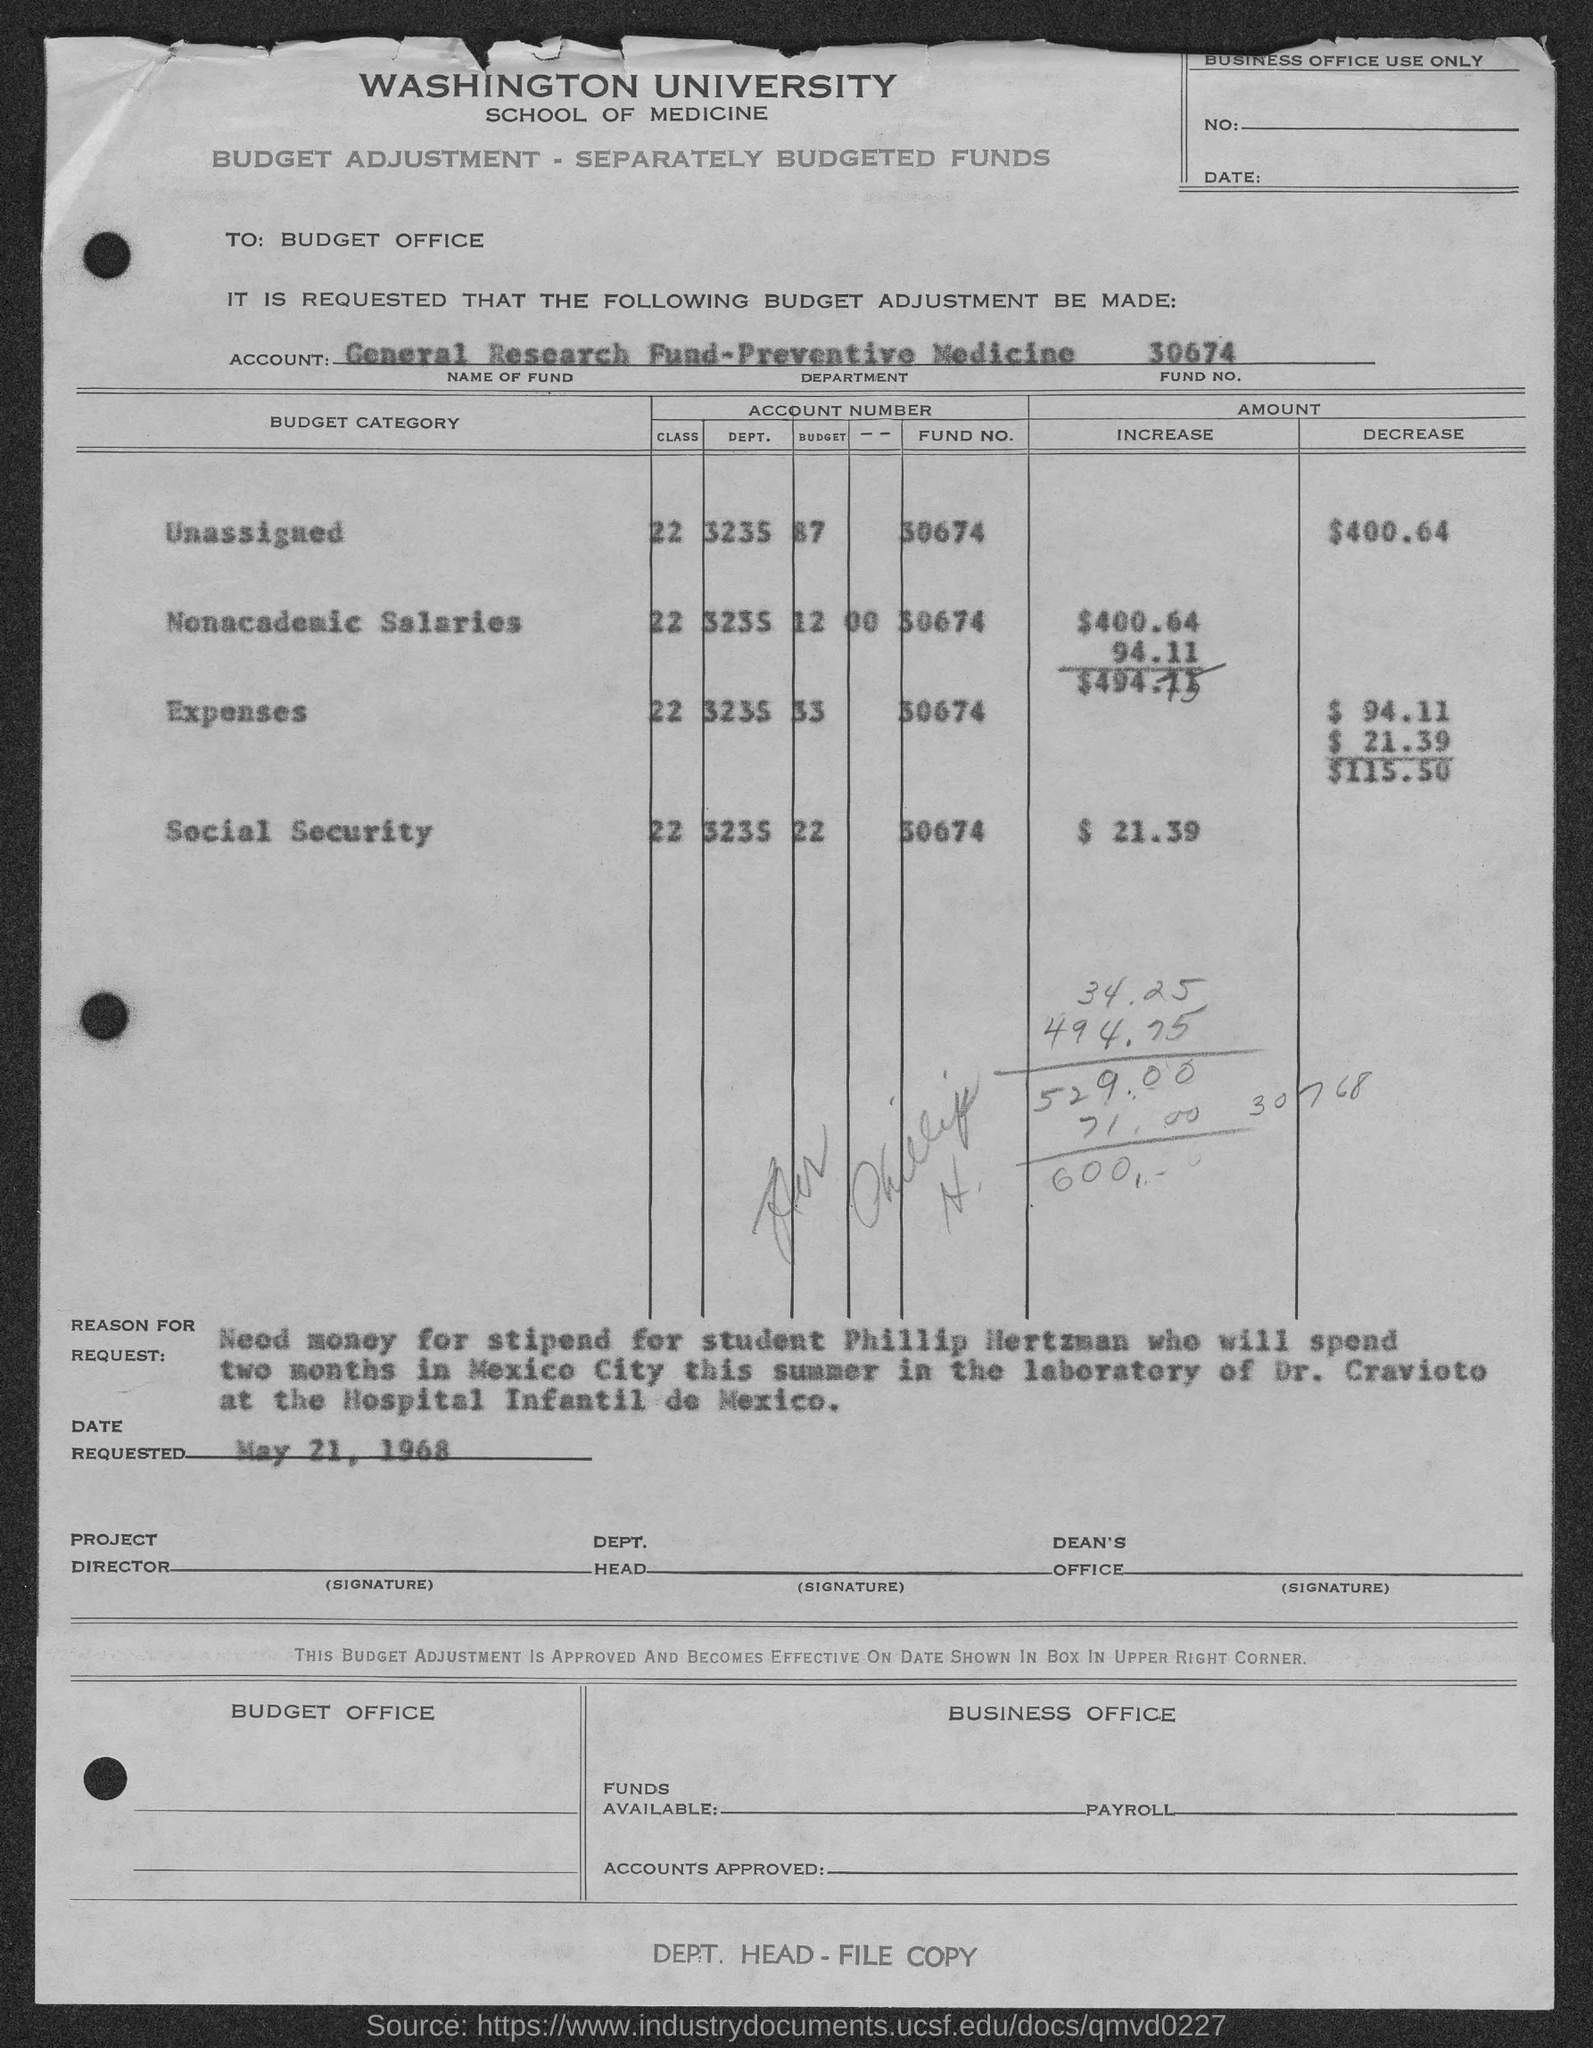Highlight a few significant elements in this photo. The Fund Number is 30674. The date requested is May 21, 1968. The stipend is for Phillip Hertzman. Preventive medicine is the department that focuses on promoting health and preventing illness and injury. The name of the fund is the General Research Fund. 